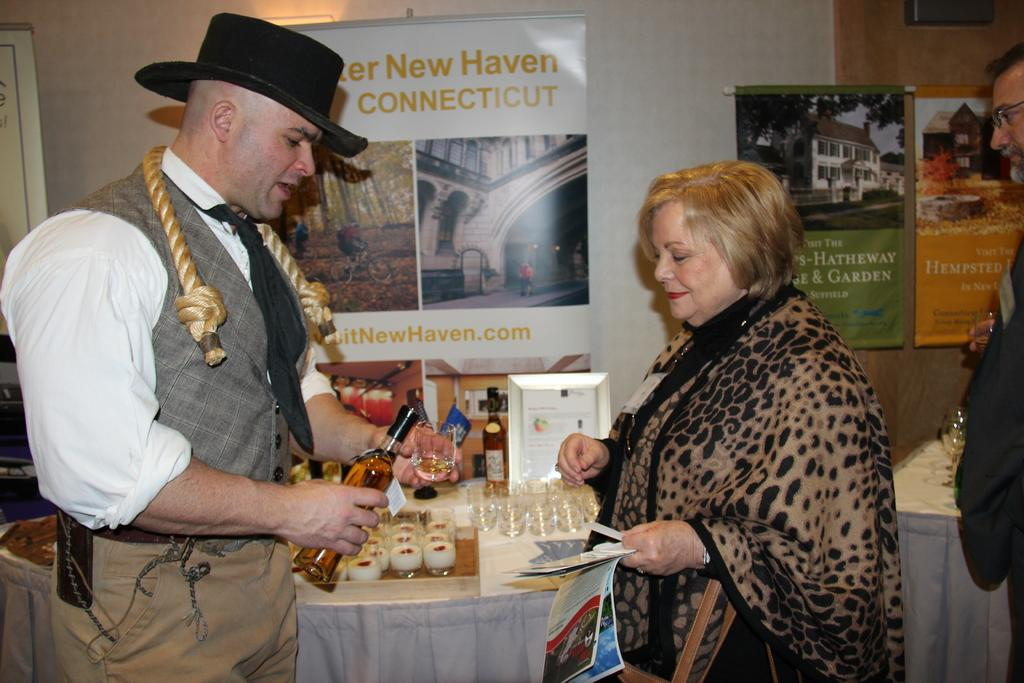How many people are in the image? There is a man and a woman in the image. What are the man and woman doing in the image? The man and woman are standing close to each other. What is the man holding in the image? The man is holding a bottle. What is present in the image that could be used for placing objects? There is a table in the image. What can be found on the table in the image? There are different items on the table. What type of polish is the man applying to the appliance in the image? There is no polish or appliance present in the image. 